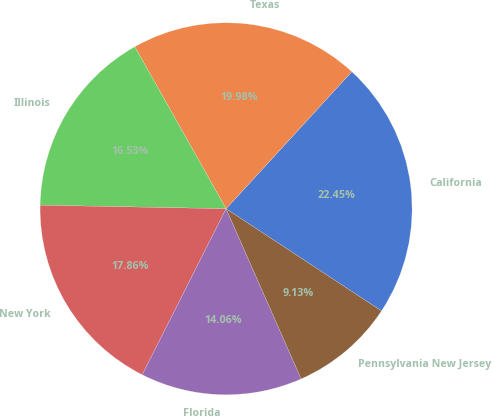<chart> <loc_0><loc_0><loc_500><loc_500><pie_chart><fcel>California<fcel>Texas<fcel>Illinois<fcel>New York<fcel>Florida<fcel>Pennsylvania New Jersey<nl><fcel>22.45%<fcel>19.98%<fcel>16.53%<fcel>17.86%<fcel>14.06%<fcel>9.13%<nl></chart> 